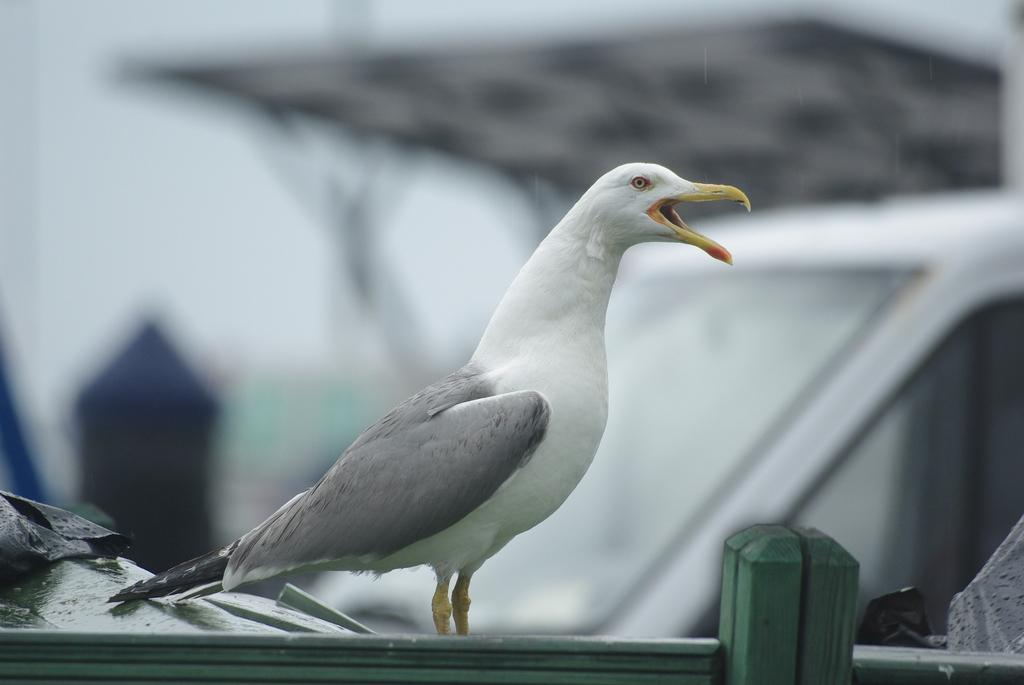What is the main subject in the foreground of the image? There is a bird in the foreground of the image. What else can be seen in the foreground of the image? There is railing and other objects in the foreground of the image. How would you describe the background of the image? The background of the image is blurred. What type of robin is feeling shame in the image? There is no robin present in the image, and no indication of shame. Can you tell me the total amount on the receipt in the image? There is no receipt present in the image. 